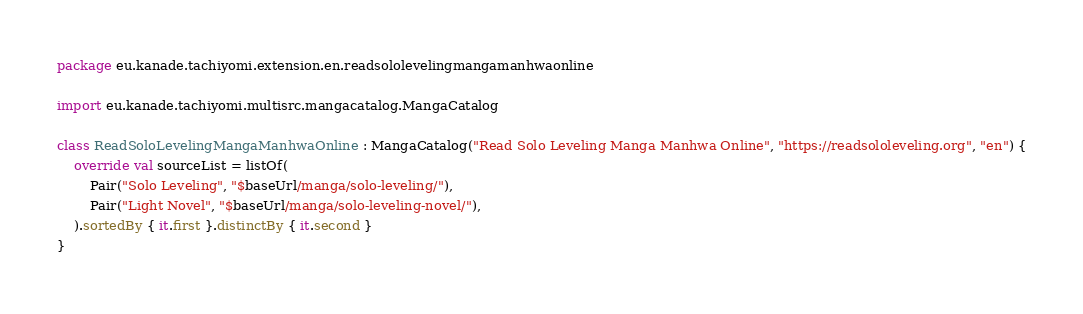<code> <loc_0><loc_0><loc_500><loc_500><_Kotlin_>package eu.kanade.tachiyomi.extension.en.readsololevelingmangamanhwaonline

import eu.kanade.tachiyomi.multisrc.mangacatalog.MangaCatalog

class ReadSoloLevelingMangaManhwaOnline : MangaCatalog("Read Solo Leveling Manga Manhwa Online", "https://readsololeveling.org", "en") {
    override val sourceList = listOf(
        Pair("Solo Leveling", "$baseUrl/manga/solo-leveling/"),
        Pair("Light Novel", "$baseUrl/manga/solo-leveling-novel/"),
    ).sortedBy { it.first }.distinctBy { it.second }
}
</code> 